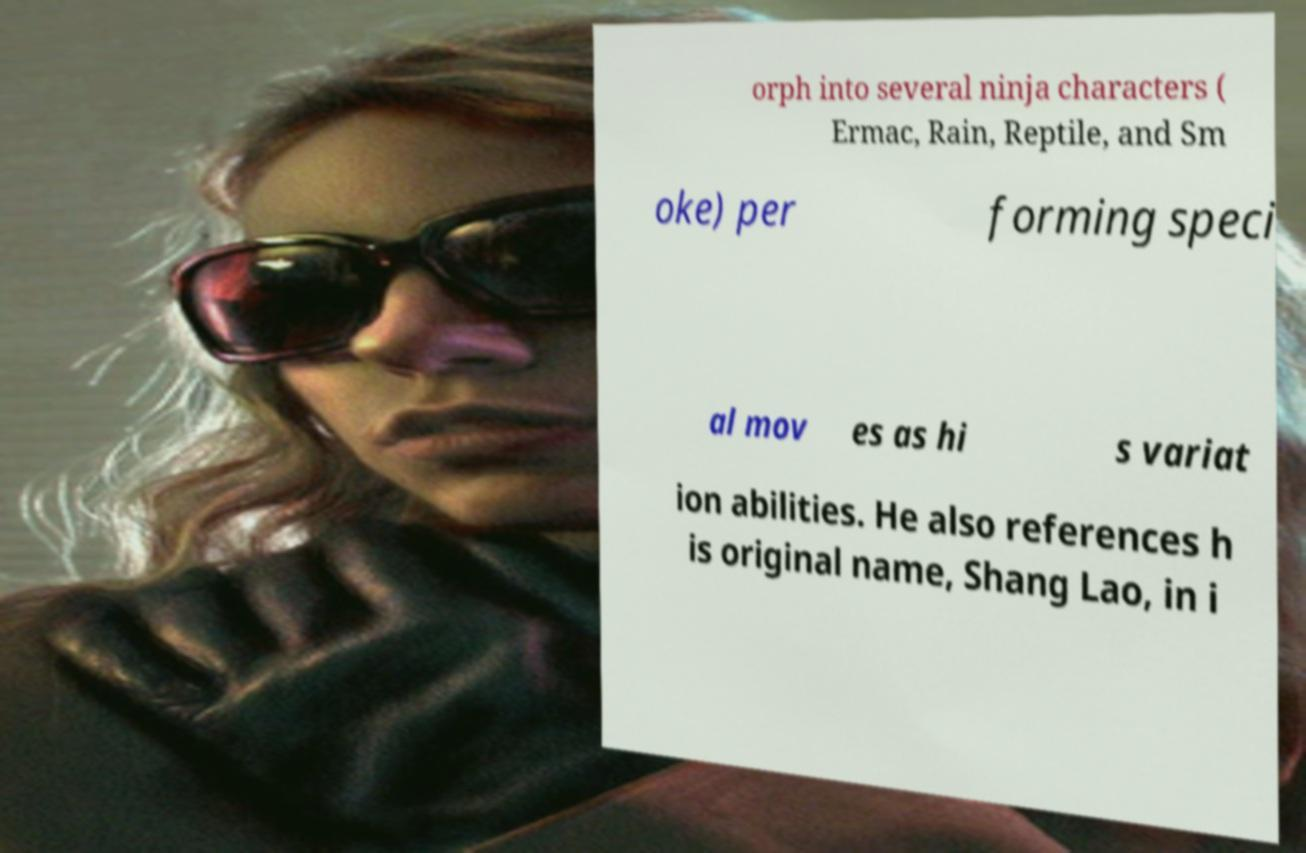What messages or text are displayed in this image? I need them in a readable, typed format. orph into several ninja characters ( Ermac, Rain, Reptile, and Sm oke) per forming speci al mov es as hi s variat ion abilities. He also references h is original name, Shang Lao, in i 